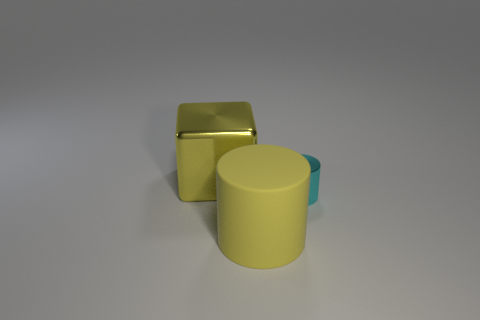Add 2 cyan metallic cylinders. How many objects exist? 5 Subtract all cyan cylinders. How many cylinders are left? 1 Subtract all cylinders. How many objects are left? 1 Subtract all yellow matte objects. Subtract all big matte cylinders. How many objects are left? 1 Add 1 yellow metallic things. How many yellow metallic things are left? 2 Add 3 big matte things. How many big matte things exist? 4 Subtract 0 brown cylinders. How many objects are left? 3 Subtract 2 cylinders. How many cylinders are left? 0 Subtract all brown cubes. Subtract all red balls. How many cubes are left? 1 Subtract all cyan cubes. How many cyan cylinders are left? 1 